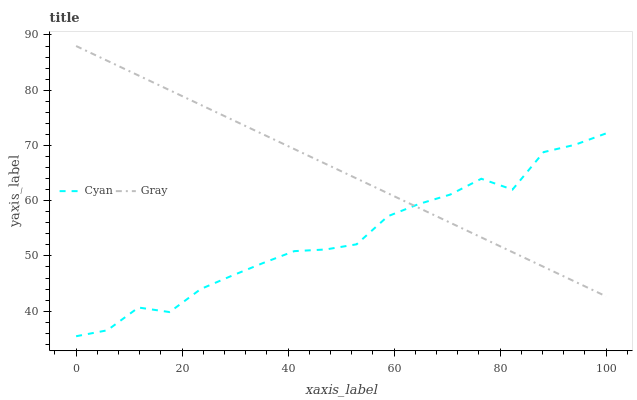Does Cyan have the minimum area under the curve?
Answer yes or no. Yes. Does Gray have the maximum area under the curve?
Answer yes or no. Yes. Does Gray have the minimum area under the curve?
Answer yes or no. No. Is Gray the smoothest?
Answer yes or no. Yes. Is Cyan the roughest?
Answer yes or no. Yes. Is Gray the roughest?
Answer yes or no. No. Does Cyan have the lowest value?
Answer yes or no. Yes. Does Gray have the lowest value?
Answer yes or no. No. Does Gray have the highest value?
Answer yes or no. Yes. Does Cyan intersect Gray?
Answer yes or no. Yes. Is Cyan less than Gray?
Answer yes or no. No. Is Cyan greater than Gray?
Answer yes or no. No. 